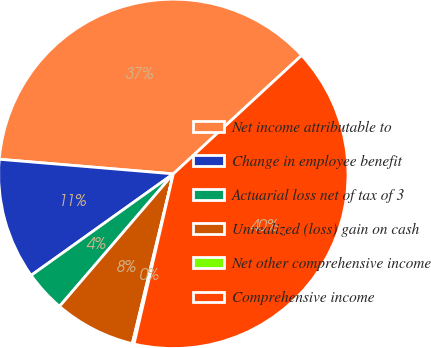Convert chart. <chart><loc_0><loc_0><loc_500><loc_500><pie_chart><fcel>Net income attributable to<fcel>Change in employee benefit<fcel>Actuarial loss net of tax of 3<fcel>Unrealized (loss) gain on cash<fcel>Net other comprehensive income<fcel>Comprehensive income<nl><fcel>36.8%<fcel>11.2%<fcel>3.84%<fcel>7.52%<fcel>0.16%<fcel>40.48%<nl></chart> 